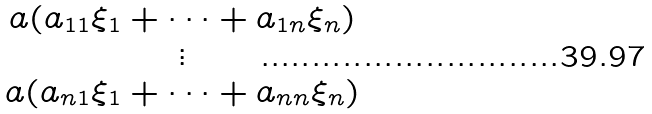<formula> <loc_0><loc_0><loc_500><loc_500>\begin{matrix} a ( a _ { 1 1 } \xi _ { 1 } + \cdots + a _ { 1 n } \xi _ { n } ) \\ \vdots \\ a ( a _ { n 1 } \xi _ { 1 } + \cdots + a _ { n n } \xi _ { n } ) \end{matrix}</formula> 